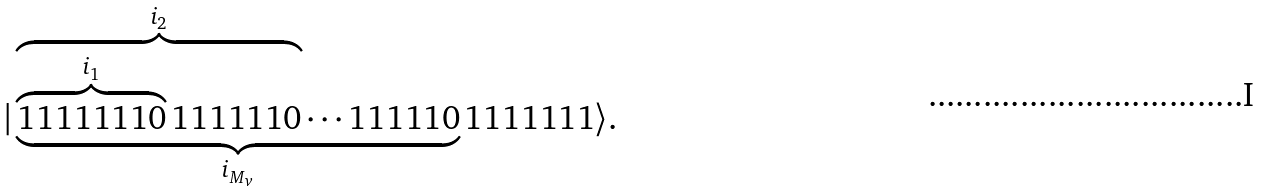<formula> <loc_0><loc_0><loc_500><loc_500>| \underbrace { \overbrace { \overbrace { 1 1 1 1 1 1 1 0 } ^ { i _ { 1 } } 1 1 1 1 1 1 0 } ^ { i _ { 2 } } \cdots 1 1 1 1 1 0 } _ { i _ { M _ { v } } } 1 1 1 1 1 1 1 \rangle .</formula> 